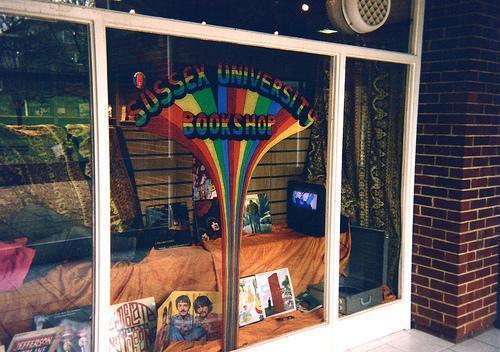How many windows are there?
Give a very brief answer. 3. 